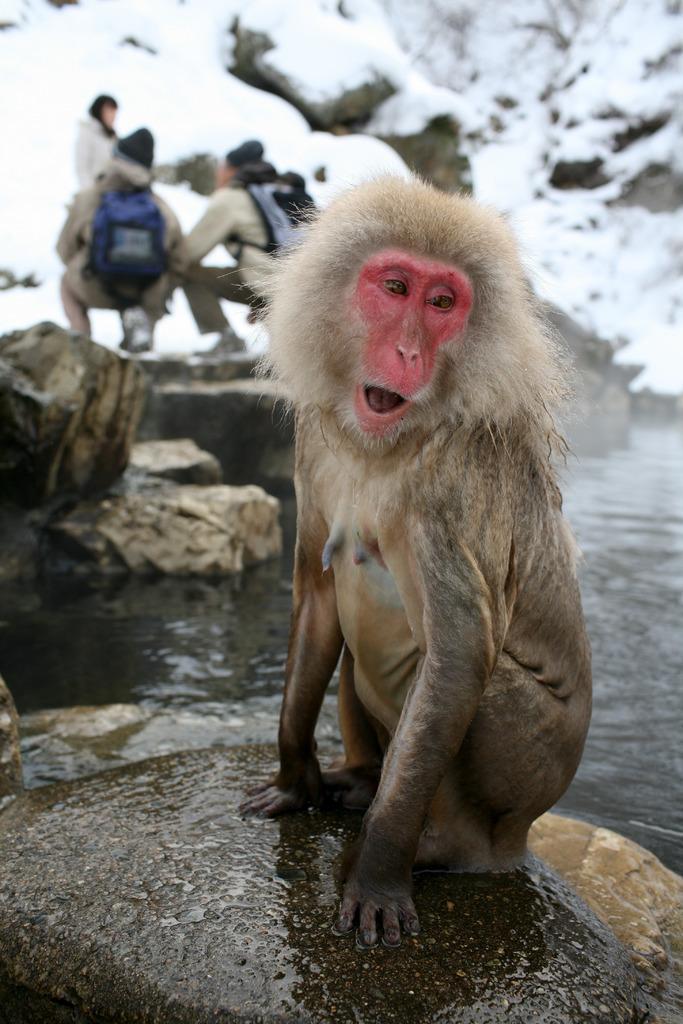Could you give a brief overview of what you see in this image? There is a monkey sitting on a rock which is wet. In the background, there are persons on the rock, there is water and there is a mountain on which, there is snow. 